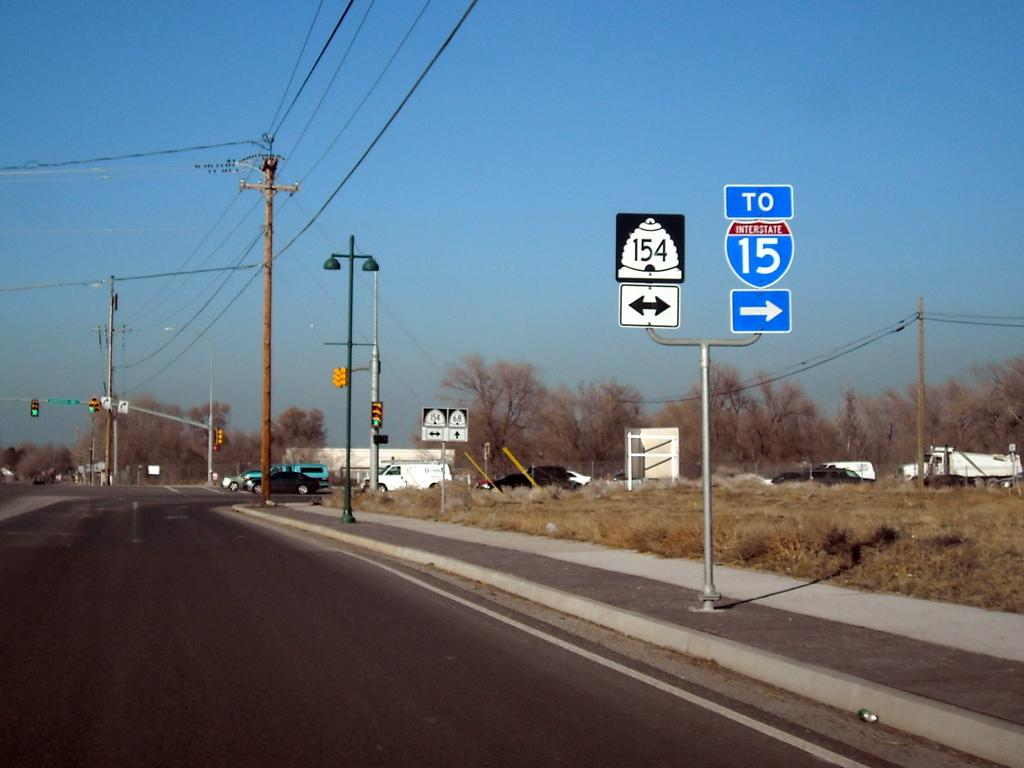<image>
Render a clear and concise summary of the photo. A highway has a sign that says To Interstate 15. 